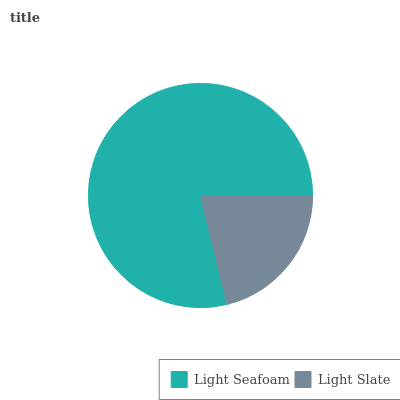Is Light Slate the minimum?
Answer yes or no. Yes. Is Light Seafoam the maximum?
Answer yes or no. Yes. Is Light Slate the maximum?
Answer yes or no. No. Is Light Seafoam greater than Light Slate?
Answer yes or no. Yes. Is Light Slate less than Light Seafoam?
Answer yes or no. Yes. Is Light Slate greater than Light Seafoam?
Answer yes or no. No. Is Light Seafoam less than Light Slate?
Answer yes or no. No. Is Light Seafoam the high median?
Answer yes or no. Yes. Is Light Slate the low median?
Answer yes or no. Yes. Is Light Slate the high median?
Answer yes or no. No. Is Light Seafoam the low median?
Answer yes or no. No. 